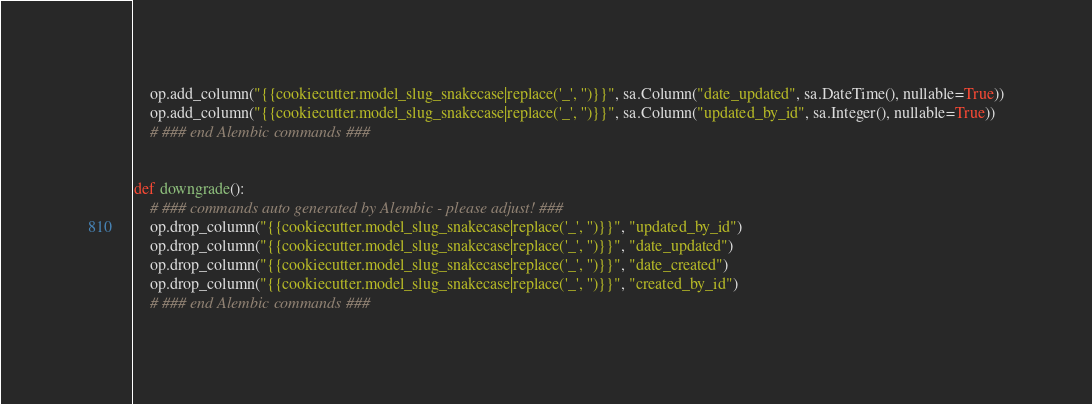Convert code to text. <code><loc_0><loc_0><loc_500><loc_500><_Python_>    op.add_column("{{cookiecutter.model_slug_snakecase|replace('_', '')}}", sa.Column("date_updated", sa.DateTime(), nullable=True))
    op.add_column("{{cookiecutter.model_slug_snakecase|replace('_', '')}}", sa.Column("updated_by_id", sa.Integer(), nullable=True))
    # ### end Alembic commands ###


def downgrade():
    # ### commands auto generated by Alembic - please adjust! ###
    op.drop_column("{{cookiecutter.model_slug_snakecase|replace('_', '')}}", "updated_by_id")
    op.drop_column("{{cookiecutter.model_slug_snakecase|replace('_', '')}}", "date_updated")
    op.drop_column("{{cookiecutter.model_slug_snakecase|replace('_', '')}}", "date_created")
    op.drop_column("{{cookiecutter.model_slug_snakecase|replace('_', '')}}", "created_by_id")
    # ### end Alembic commands ###
</code> 